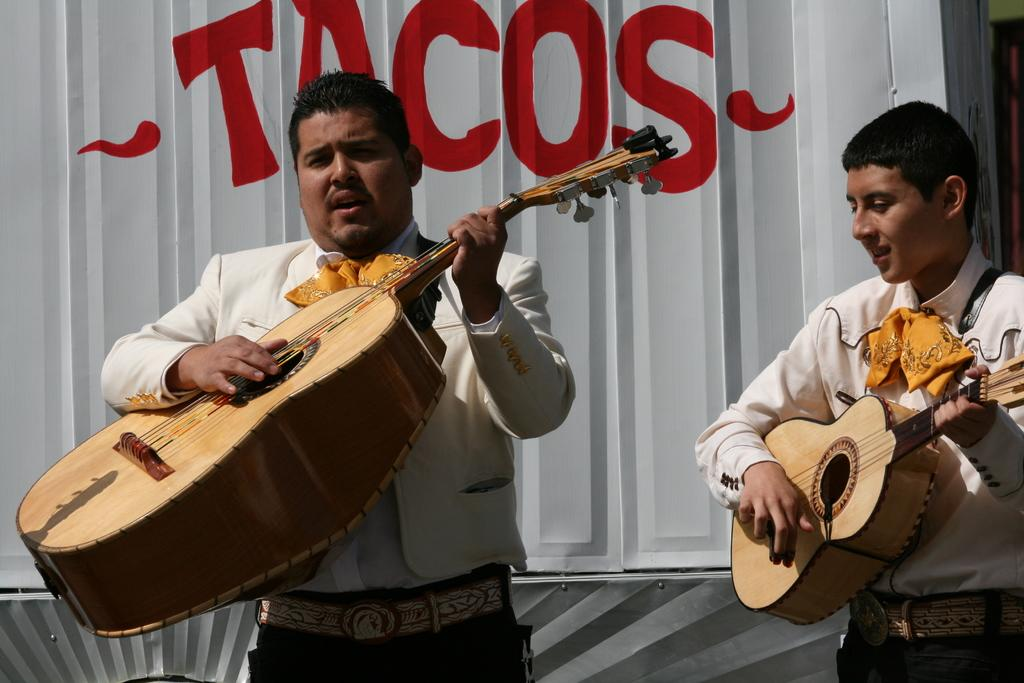How many people are in the image? There are two persons in the image. What are the persons doing in the image? The persons are holding musical instruments. What can be seen in the background of the image? There is a metal wall in the background of the image. What type of pan is hanging on the door in the image? There is no pan or door present in the image; it only features two persons holding musical instruments and a metal wall in the background. 